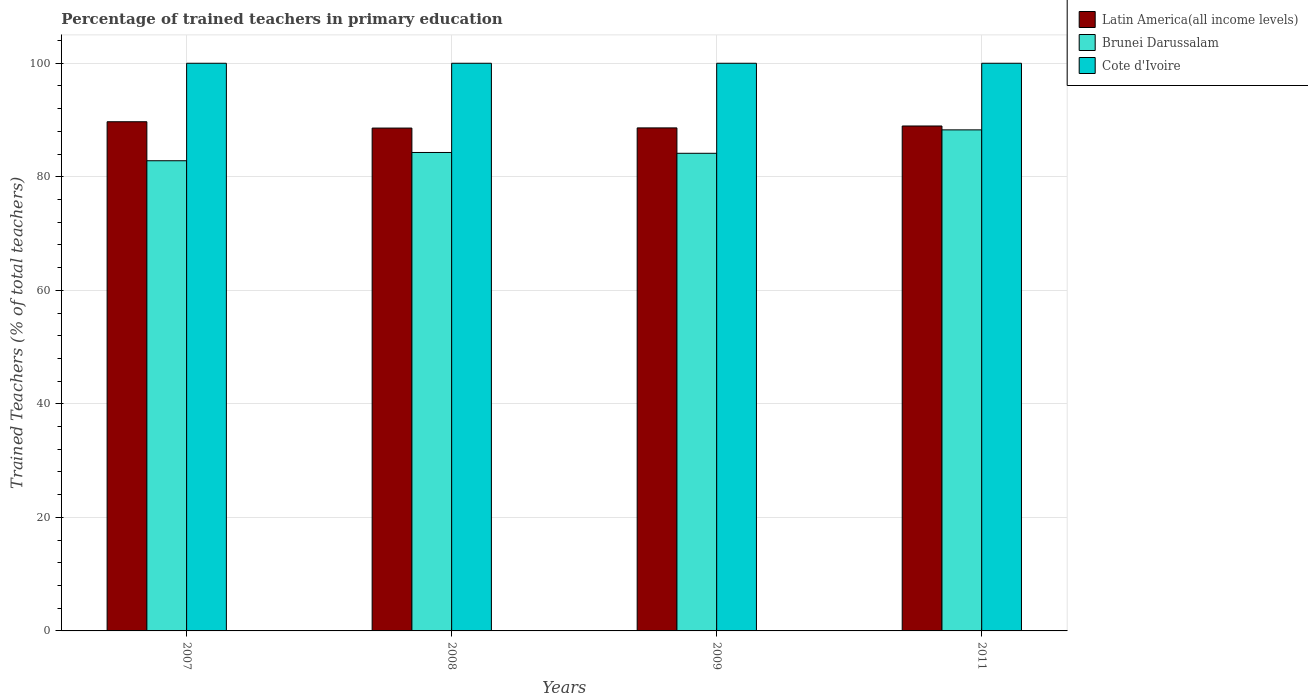How many different coloured bars are there?
Offer a terse response. 3. Are the number of bars on each tick of the X-axis equal?
Offer a terse response. Yes. In how many cases, is the number of bars for a given year not equal to the number of legend labels?
Ensure brevity in your answer.  0. What is the percentage of trained teachers in Brunei Darussalam in 2007?
Offer a very short reply. 82.83. In which year was the percentage of trained teachers in Brunei Darussalam minimum?
Offer a terse response. 2007. What is the total percentage of trained teachers in Latin America(all income levels) in the graph?
Make the answer very short. 355.84. What is the difference between the percentage of trained teachers in Cote d'Ivoire in 2008 and that in 2009?
Provide a succinct answer. 0. What is the difference between the percentage of trained teachers in Cote d'Ivoire in 2011 and the percentage of trained teachers in Brunei Darussalam in 2009?
Keep it short and to the point. 15.86. In the year 2007, what is the difference between the percentage of trained teachers in Latin America(all income levels) and percentage of trained teachers in Cote d'Ivoire?
Ensure brevity in your answer.  -10.3. In how many years, is the percentage of trained teachers in Brunei Darussalam greater than 44 %?
Give a very brief answer. 4. What is the ratio of the percentage of trained teachers in Brunei Darussalam in 2008 to that in 2011?
Provide a short and direct response. 0.95. What is the difference between the highest and the second highest percentage of trained teachers in Latin America(all income levels)?
Make the answer very short. 0.75. What is the difference between the highest and the lowest percentage of trained teachers in Brunei Darussalam?
Provide a succinct answer. 5.44. What does the 1st bar from the left in 2011 represents?
Ensure brevity in your answer.  Latin America(all income levels). What does the 3rd bar from the right in 2011 represents?
Your response must be concise. Latin America(all income levels). Is it the case that in every year, the sum of the percentage of trained teachers in Latin America(all income levels) and percentage of trained teachers in Brunei Darussalam is greater than the percentage of trained teachers in Cote d'Ivoire?
Provide a succinct answer. Yes. How many years are there in the graph?
Offer a terse response. 4. Are the values on the major ticks of Y-axis written in scientific E-notation?
Offer a very short reply. No. What is the title of the graph?
Your answer should be compact. Percentage of trained teachers in primary education. What is the label or title of the Y-axis?
Your answer should be very brief. Trained Teachers (% of total teachers). What is the Trained Teachers (% of total teachers) in Latin America(all income levels) in 2007?
Provide a short and direct response. 89.7. What is the Trained Teachers (% of total teachers) in Brunei Darussalam in 2007?
Your response must be concise. 82.83. What is the Trained Teachers (% of total teachers) in Latin America(all income levels) in 2008?
Your response must be concise. 88.58. What is the Trained Teachers (% of total teachers) in Brunei Darussalam in 2008?
Your answer should be very brief. 84.28. What is the Trained Teachers (% of total teachers) of Latin America(all income levels) in 2009?
Offer a very short reply. 88.61. What is the Trained Teachers (% of total teachers) in Brunei Darussalam in 2009?
Your response must be concise. 84.14. What is the Trained Teachers (% of total teachers) in Latin America(all income levels) in 2011?
Keep it short and to the point. 88.95. What is the Trained Teachers (% of total teachers) in Brunei Darussalam in 2011?
Offer a terse response. 88.27. What is the Trained Teachers (% of total teachers) of Cote d'Ivoire in 2011?
Ensure brevity in your answer.  100. Across all years, what is the maximum Trained Teachers (% of total teachers) in Latin America(all income levels)?
Your answer should be compact. 89.7. Across all years, what is the maximum Trained Teachers (% of total teachers) of Brunei Darussalam?
Your response must be concise. 88.27. Across all years, what is the maximum Trained Teachers (% of total teachers) of Cote d'Ivoire?
Ensure brevity in your answer.  100. Across all years, what is the minimum Trained Teachers (% of total teachers) of Latin America(all income levels)?
Make the answer very short. 88.58. Across all years, what is the minimum Trained Teachers (% of total teachers) in Brunei Darussalam?
Give a very brief answer. 82.83. Across all years, what is the minimum Trained Teachers (% of total teachers) in Cote d'Ivoire?
Provide a succinct answer. 100. What is the total Trained Teachers (% of total teachers) of Latin America(all income levels) in the graph?
Make the answer very short. 355.84. What is the total Trained Teachers (% of total teachers) in Brunei Darussalam in the graph?
Your answer should be very brief. 339.52. What is the difference between the Trained Teachers (% of total teachers) in Latin America(all income levels) in 2007 and that in 2008?
Provide a short and direct response. 1.11. What is the difference between the Trained Teachers (% of total teachers) of Brunei Darussalam in 2007 and that in 2008?
Your answer should be very brief. -1.46. What is the difference between the Trained Teachers (% of total teachers) of Latin America(all income levels) in 2007 and that in 2009?
Offer a very short reply. 1.08. What is the difference between the Trained Teachers (% of total teachers) in Brunei Darussalam in 2007 and that in 2009?
Keep it short and to the point. -1.31. What is the difference between the Trained Teachers (% of total teachers) of Cote d'Ivoire in 2007 and that in 2009?
Your answer should be compact. 0. What is the difference between the Trained Teachers (% of total teachers) of Latin America(all income levels) in 2007 and that in 2011?
Offer a terse response. 0.75. What is the difference between the Trained Teachers (% of total teachers) in Brunei Darussalam in 2007 and that in 2011?
Your answer should be compact. -5.44. What is the difference between the Trained Teachers (% of total teachers) of Latin America(all income levels) in 2008 and that in 2009?
Offer a terse response. -0.03. What is the difference between the Trained Teachers (% of total teachers) in Brunei Darussalam in 2008 and that in 2009?
Offer a very short reply. 0.14. What is the difference between the Trained Teachers (% of total teachers) of Latin America(all income levels) in 2008 and that in 2011?
Ensure brevity in your answer.  -0.37. What is the difference between the Trained Teachers (% of total teachers) in Brunei Darussalam in 2008 and that in 2011?
Keep it short and to the point. -3.98. What is the difference between the Trained Teachers (% of total teachers) in Cote d'Ivoire in 2008 and that in 2011?
Offer a very short reply. 0. What is the difference between the Trained Teachers (% of total teachers) in Latin America(all income levels) in 2009 and that in 2011?
Keep it short and to the point. -0.34. What is the difference between the Trained Teachers (% of total teachers) in Brunei Darussalam in 2009 and that in 2011?
Give a very brief answer. -4.13. What is the difference between the Trained Teachers (% of total teachers) of Latin America(all income levels) in 2007 and the Trained Teachers (% of total teachers) of Brunei Darussalam in 2008?
Your response must be concise. 5.41. What is the difference between the Trained Teachers (% of total teachers) in Latin America(all income levels) in 2007 and the Trained Teachers (% of total teachers) in Cote d'Ivoire in 2008?
Your response must be concise. -10.3. What is the difference between the Trained Teachers (% of total teachers) of Brunei Darussalam in 2007 and the Trained Teachers (% of total teachers) of Cote d'Ivoire in 2008?
Provide a short and direct response. -17.17. What is the difference between the Trained Teachers (% of total teachers) of Latin America(all income levels) in 2007 and the Trained Teachers (% of total teachers) of Brunei Darussalam in 2009?
Keep it short and to the point. 5.56. What is the difference between the Trained Teachers (% of total teachers) of Latin America(all income levels) in 2007 and the Trained Teachers (% of total teachers) of Cote d'Ivoire in 2009?
Offer a very short reply. -10.3. What is the difference between the Trained Teachers (% of total teachers) in Brunei Darussalam in 2007 and the Trained Teachers (% of total teachers) in Cote d'Ivoire in 2009?
Your answer should be very brief. -17.17. What is the difference between the Trained Teachers (% of total teachers) in Latin America(all income levels) in 2007 and the Trained Teachers (% of total teachers) in Brunei Darussalam in 2011?
Your response must be concise. 1.43. What is the difference between the Trained Teachers (% of total teachers) in Latin America(all income levels) in 2007 and the Trained Teachers (% of total teachers) in Cote d'Ivoire in 2011?
Ensure brevity in your answer.  -10.3. What is the difference between the Trained Teachers (% of total teachers) of Brunei Darussalam in 2007 and the Trained Teachers (% of total teachers) of Cote d'Ivoire in 2011?
Make the answer very short. -17.17. What is the difference between the Trained Teachers (% of total teachers) in Latin America(all income levels) in 2008 and the Trained Teachers (% of total teachers) in Brunei Darussalam in 2009?
Offer a very short reply. 4.44. What is the difference between the Trained Teachers (% of total teachers) of Latin America(all income levels) in 2008 and the Trained Teachers (% of total teachers) of Cote d'Ivoire in 2009?
Your response must be concise. -11.42. What is the difference between the Trained Teachers (% of total teachers) of Brunei Darussalam in 2008 and the Trained Teachers (% of total teachers) of Cote d'Ivoire in 2009?
Offer a terse response. -15.72. What is the difference between the Trained Teachers (% of total teachers) in Latin America(all income levels) in 2008 and the Trained Teachers (% of total teachers) in Brunei Darussalam in 2011?
Make the answer very short. 0.32. What is the difference between the Trained Teachers (% of total teachers) of Latin America(all income levels) in 2008 and the Trained Teachers (% of total teachers) of Cote d'Ivoire in 2011?
Give a very brief answer. -11.42. What is the difference between the Trained Teachers (% of total teachers) of Brunei Darussalam in 2008 and the Trained Teachers (% of total teachers) of Cote d'Ivoire in 2011?
Your answer should be very brief. -15.72. What is the difference between the Trained Teachers (% of total teachers) of Latin America(all income levels) in 2009 and the Trained Teachers (% of total teachers) of Brunei Darussalam in 2011?
Your response must be concise. 0.34. What is the difference between the Trained Teachers (% of total teachers) of Latin America(all income levels) in 2009 and the Trained Teachers (% of total teachers) of Cote d'Ivoire in 2011?
Offer a very short reply. -11.39. What is the difference between the Trained Teachers (% of total teachers) in Brunei Darussalam in 2009 and the Trained Teachers (% of total teachers) in Cote d'Ivoire in 2011?
Offer a terse response. -15.86. What is the average Trained Teachers (% of total teachers) of Latin America(all income levels) per year?
Provide a succinct answer. 88.96. What is the average Trained Teachers (% of total teachers) of Brunei Darussalam per year?
Keep it short and to the point. 84.88. What is the average Trained Teachers (% of total teachers) of Cote d'Ivoire per year?
Offer a very short reply. 100. In the year 2007, what is the difference between the Trained Teachers (% of total teachers) in Latin America(all income levels) and Trained Teachers (% of total teachers) in Brunei Darussalam?
Keep it short and to the point. 6.87. In the year 2007, what is the difference between the Trained Teachers (% of total teachers) in Latin America(all income levels) and Trained Teachers (% of total teachers) in Cote d'Ivoire?
Make the answer very short. -10.3. In the year 2007, what is the difference between the Trained Teachers (% of total teachers) of Brunei Darussalam and Trained Teachers (% of total teachers) of Cote d'Ivoire?
Give a very brief answer. -17.17. In the year 2008, what is the difference between the Trained Teachers (% of total teachers) in Latin America(all income levels) and Trained Teachers (% of total teachers) in Brunei Darussalam?
Your response must be concise. 4.3. In the year 2008, what is the difference between the Trained Teachers (% of total teachers) of Latin America(all income levels) and Trained Teachers (% of total teachers) of Cote d'Ivoire?
Give a very brief answer. -11.42. In the year 2008, what is the difference between the Trained Teachers (% of total teachers) in Brunei Darussalam and Trained Teachers (% of total teachers) in Cote d'Ivoire?
Make the answer very short. -15.72. In the year 2009, what is the difference between the Trained Teachers (% of total teachers) in Latin America(all income levels) and Trained Teachers (% of total teachers) in Brunei Darussalam?
Give a very brief answer. 4.47. In the year 2009, what is the difference between the Trained Teachers (% of total teachers) in Latin America(all income levels) and Trained Teachers (% of total teachers) in Cote d'Ivoire?
Your answer should be very brief. -11.39. In the year 2009, what is the difference between the Trained Teachers (% of total teachers) in Brunei Darussalam and Trained Teachers (% of total teachers) in Cote d'Ivoire?
Offer a very short reply. -15.86. In the year 2011, what is the difference between the Trained Teachers (% of total teachers) in Latin America(all income levels) and Trained Teachers (% of total teachers) in Brunei Darussalam?
Your response must be concise. 0.68. In the year 2011, what is the difference between the Trained Teachers (% of total teachers) in Latin America(all income levels) and Trained Teachers (% of total teachers) in Cote d'Ivoire?
Make the answer very short. -11.05. In the year 2011, what is the difference between the Trained Teachers (% of total teachers) in Brunei Darussalam and Trained Teachers (% of total teachers) in Cote d'Ivoire?
Provide a succinct answer. -11.73. What is the ratio of the Trained Teachers (% of total teachers) in Latin America(all income levels) in 2007 to that in 2008?
Give a very brief answer. 1.01. What is the ratio of the Trained Teachers (% of total teachers) in Brunei Darussalam in 2007 to that in 2008?
Your answer should be very brief. 0.98. What is the ratio of the Trained Teachers (% of total teachers) of Cote d'Ivoire in 2007 to that in 2008?
Keep it short and to the point. 1. What is the ratio of the Trained Teachers (% of total teachers) of Latin America(all income levels) in 2007 to that in 2009?
Ensure brevity in your answer.  1.01. What is the ratio of the Trained Teachers (% of total teachers) in Brunei Darussalam in 2007 to that in 2009?
Provide a short and direct response. 0.98. What is the ratio of the Trained Teachers (% of total teachers) in Latin America(all income levels) in 2007 to that in 2011?
Offer a very short reply. 1.01. What is the ratio of the Trained Teachers (% of total teachers) of Brunei Darussalam in 2007 to that in 2011?
Provide a succinct answer. 0.94. What is the ratio of the Trained Teachers (% of total teachers) of Latin America(all income levels) in 2008 to that in 2009?
Offer a terse response. 1. What is the ratio of the Trained Teachers (% of total teachers) of Brunei Darussalam in 2008 to that in 2009?
Make the answer very short. 1. What is the ratio of the Trained Teachers (% of total teachers) of Brunei Darussalam in 2008 to that in 2011?
Provide a short and direct response. 0.95. What is the ratio of the Trained Teachers (% of total teachers) in Latin America(all income levels) in 2009 to that in 2011?
Offer a terse response. 1. What is the ratio of the Trained Teachers (% of total teachers) in Brunei Darussalam in 2009 to that in 2011?
Keep it short and to the point. 0.95. What is the ratio of the Trained Teachers (% of total teachers) in Cote d'Ivoire in 2009 to that in 2011?
Make the answer very short. 1. What is the difference between the highest and the second highest Trained Teachers (% of total teachers) in Latin America(all income levels)?
Provide a short and direct response. 0.75. What is the difference between the highest and the second highest Trained Teachers (% of total teachers) of Brunei Darussalam?
Ensure brevity in your answer.  3.98. What is the difference between the highest and the lowest Trained Teachers (% of total teachers) in Latin America(all income levels)?
Keep it short and to the point. 1.11. What is the difference between the highest and the lowest Trained Teachers (% of total teachers) of Brunei Darussalam?
Offer a very short reply. 5.44. 